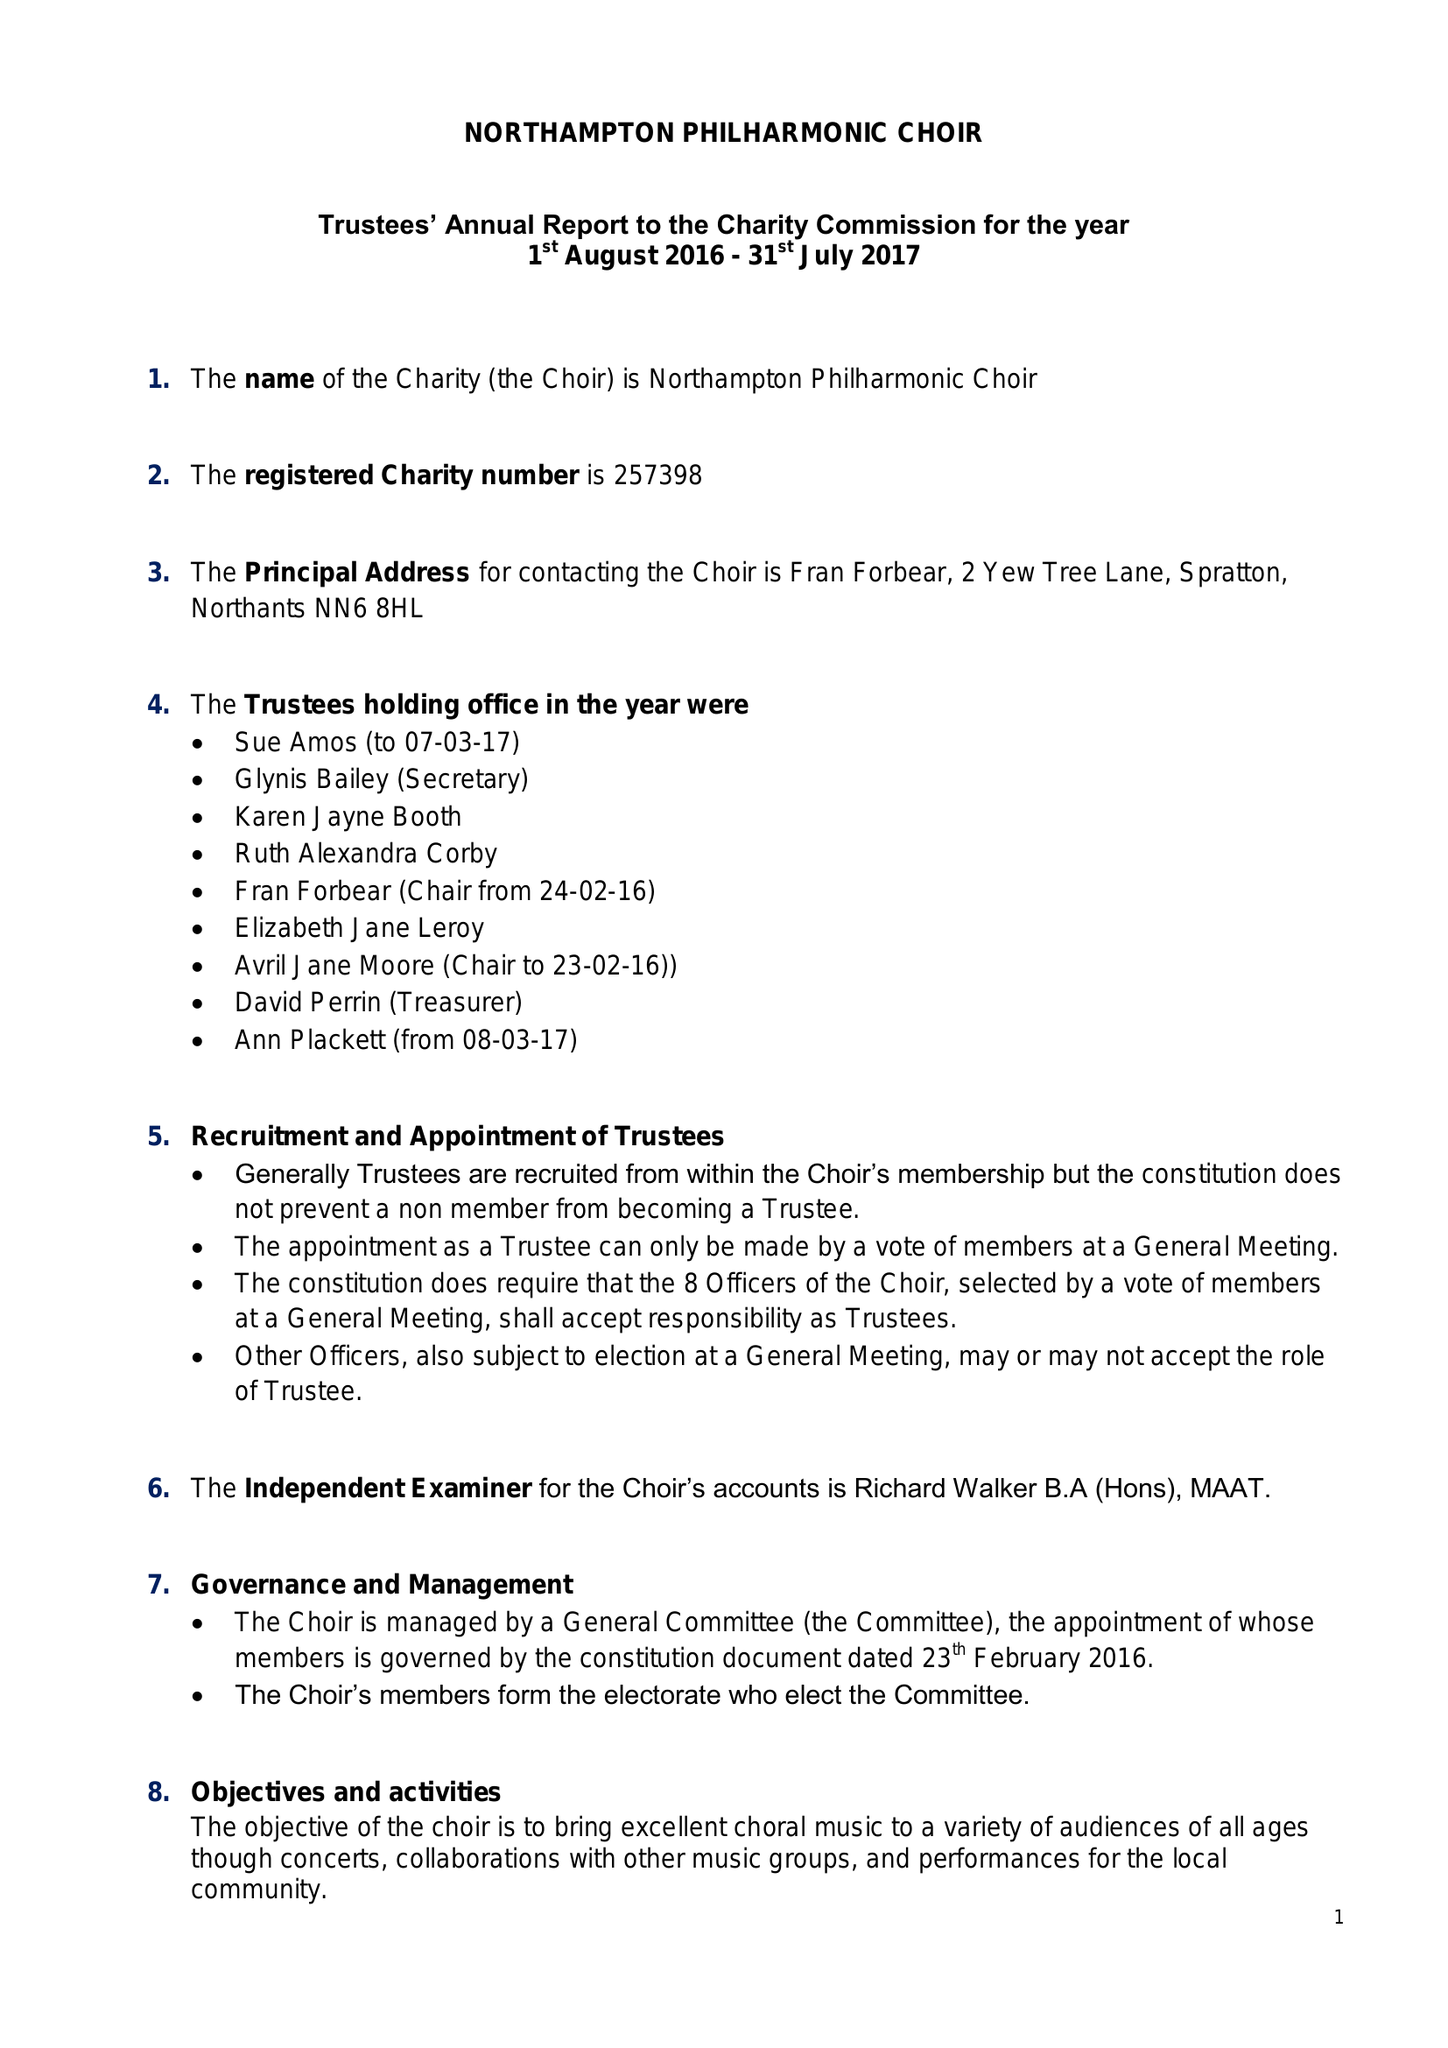What is the value for the spending_annually_in_british_pounds?
Answer the question using a single word or phrase. 24287.00 